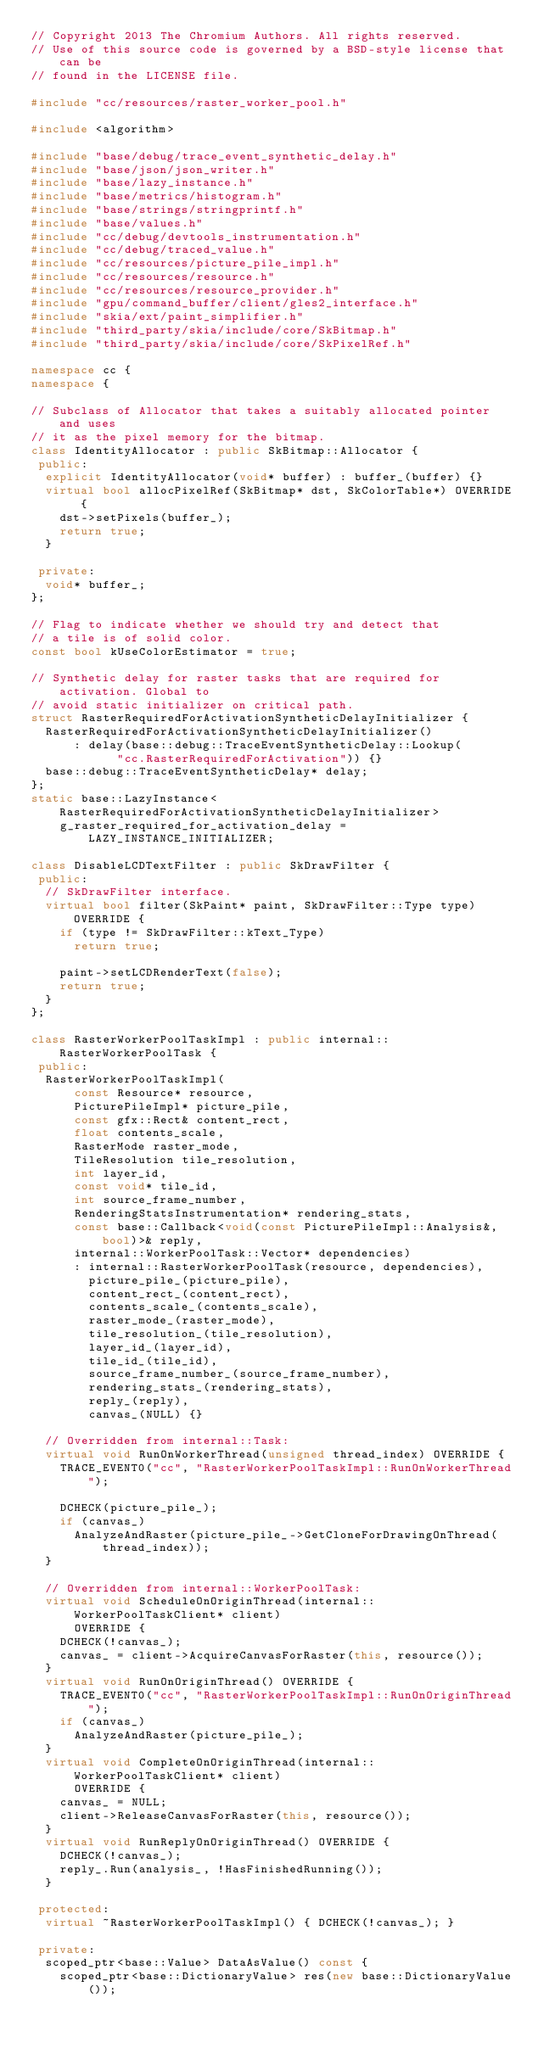<code> <loc_0><loc_0><loc_500><loc_500><_C++_>// Copyright 2013 The Chromium Authors. All rights reserved.
// Use of this source code is governed by a BSD-style license that can be
// found in the LICENSE file.

#include "cc/resources/raster_worker_pool.h"

#include <algorithm>

#include "base/debug/trace_event_synthetic_delay.h"
#include "base/json/json_writer.h"
#include "base/lazy_instance.h"
#include "base/metrics/histogram.h"
#include "base/strings/stringprintf.h"
#include "base/values.h"
#include "cc/debug/devtools_instrumentation.h"
#include "cc/debug/traced_value.h"
#include "cc/resources/picture_pile_impl.h"
#include "cc/resources/resource.h"
#include "cc/resources/resource_provider.h"
#include "gpu/command_buffer/client/gles2_interface.h"
#include "skia/ext/paint_simplifier.h"
#include "third_party/skia/include/core/SkBitmap.h"
#include "third_party/skia/include/core/SkPixelRef.h"

namespace cc {
namespace {

// Subclass of Allocator that takes a suitably allocated pointer and uses
// it as the pixel memory for the bitmap.
class IdentityAllocator : public SkBitmap::Allocator {
 public:
  explicit IdentityAllocator(void* buffer) : buffer_(buffer) {}
  virtual bool allocPixelRef(SkBitmap* dst, SkColorTable*) OVERRIDE {
    dst->setPixels(buffer_);
    return true;
  }

 private:
  void* buffer_;
};

// Flag to indicate whether we should try and detect that
// a tile is of solid color.
const bool kUseColorEstimator = true;

// Synthetic delay for raster tasks that are required for activation. Global to
// avoid static initializer on critical path.
struct RasterRequiredForActivationSyntheticDelayInitializer {
  RasterRequiredForActivationSyntheticDelayInitializer()
      : delay(base::debug::TraceEventSyntheticDelay::Lookup(
            "cc.RasterRequiredForActivation")) {}
  base::debug::TraceEventSyntheticDelay* delay;
};
static base::LazyInstance<RasterRequiredForActivationSyntheticDelayInitializer>
    g_raster_required_for_activation_delay = LAZY_INSTANCE_INITIALIZER;

class DisableLCDTextFilter : public SkDrawFilter {
 public:
  // SkDrawFilter interface.
  virtual bool filter(SkPaint* paint, SkDrawFilter::Type type) OVERRIDE {
    if (type != SkDrawFilter::kText_Type)
      return true;

    paint->setLCDRenderText(false);
    return true;
  }
};

class RasterWorkerPoolTaskImpl : public internal::RasterWorkerPoolTask {
 public:
  RasterWorkerPoolTaskImpl(
      const Resource* resource,
      PicturePileImpl* picture_pile,
      const gfx::Rect& content_rect,
      float contents_scale,
      RasterMode raster_mode,
      TileResolution tile_resolution,
      int layer_id,
      const void* tile_id,
      int source_frame_number,
      RenderingStatsInstrumentation* rendering_stats,
      const base::Callback<void(const PicturePileImpl::Analysis&, bool)>& reply,
      internal::WorkerPoolTask::Vector* dependencies)
      : internal::RasterWorkerPoolTask(resource, dependencies),
        picture_pile_(picture_pile),
        content_rect_(content_rect),
        contents_scale_(contents_scale),
        raster_mode_(raster_mode),
        tile_resolution_(tile_resolution),
        layer_id_(layer_id),
        tile_id_(tile_id),
        source_frame_number_(source_frame_number),
        rendering_stats_(rendering_stats),
        reply_(reply),
        canvas_(NULL) {}

  // Overridden from internal::Task:
  virtual void RunOnWorkerThread(unsigned thread_index) OVERRIDE {
    TRACE_EVENT0("cc", "RasterWorkerPoolTaskImpl::RunOnWorkerThread");

    DCHECK(picture_pile_);
    if (canvas_)
      AnalyzeAndRaster(picture_pile_->GetCloneForDrawingOnThread(thread_index));
  }

  // Overridden from internal::WorkerPoolTask:
  virtual void ScheduleOnOriginThread(internal::WorkerPoolTaskClient* client)
      OVERRIDE {
    DCHECK(!canvas_);
    canvas_ = client->AcquireCanvasForRaster(this, resource());
  }
  virtual void RunOnOriginThread() OVERRIDE {
    TRACE_EVENT0("cc", "RasterWorkerPoolTaskImpl::RunOnOriginThread");
    if (canvas_)
      AnalyzeAndRaster(picture_pile_);
  }
  virtual void CompleteOnOriginThread(internal::WorkerPoolTaskClient* client)
      OVERRIDE {
    canvas_ = NULL;
    client->ReleaseCanvasForRaster(this, resource());
  }
  virtual void RunReplyOnOriginThread() OVERRIDE {
    DCHECK(!canvas_);
    reply_.Run(analysis_, !HasFinishedRunning());
  }

 protected:
  virtual ~RasterWorkerPoolTaskImpl() { DCHECK(!canvas_); }

 private:
  scoped_ptr<base::Value> DataAsValue() const {
    scoped_ptr<base::DictionaryValue> res(new base::DictionaryValue());</code> 